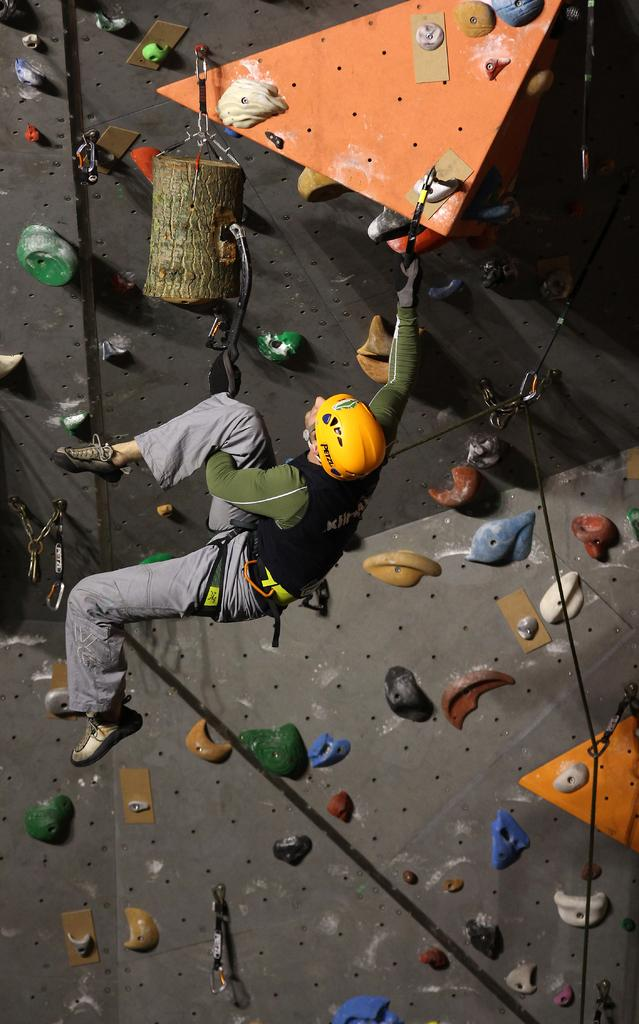What is the main subject of the image? There is a person in the image. What type of clothing is the person wearing? The person is wearing a jacket and trousers. What protective gear is the person wearing? The person is wearing a helmet on their head. What activity is the person engaged in? The person is engaged in Bouldering. What direction is the person looking in? The person is looking upwards. How many clovers can be seen growing near the person in the image? There are no clovers visible in the image. Are there any boys present in the image? The image does not show any boys; it only features one person. 